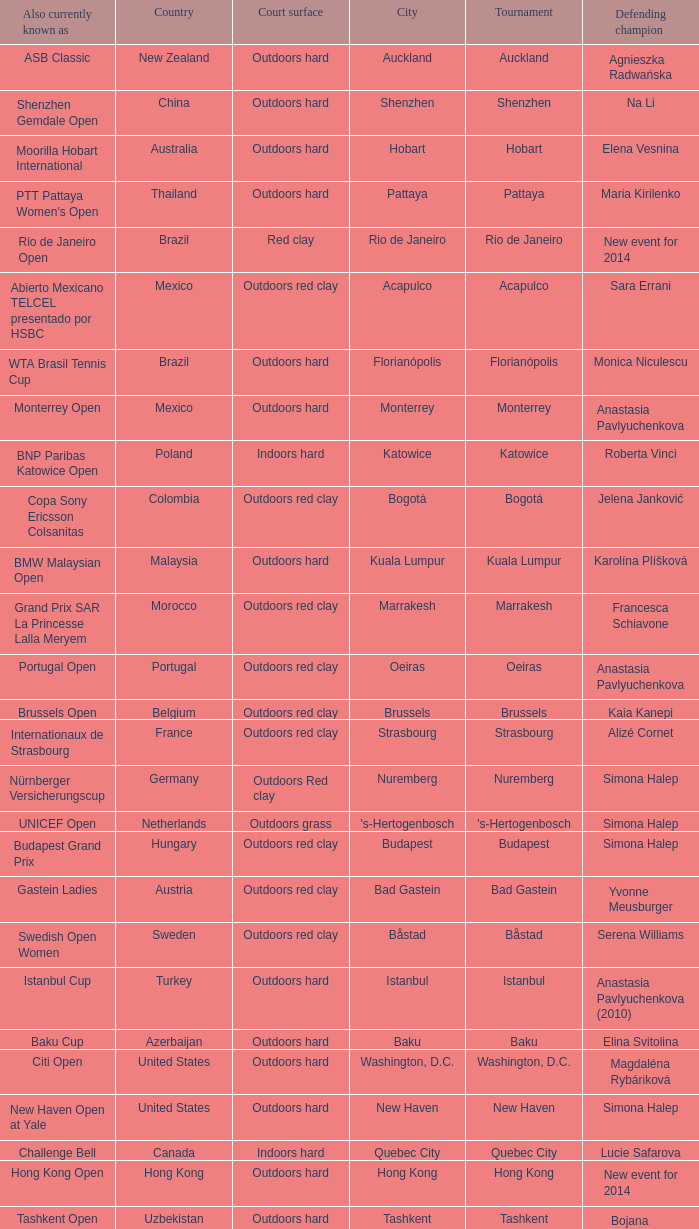How many tournaments are also currently known as the hp open? 1.0. 